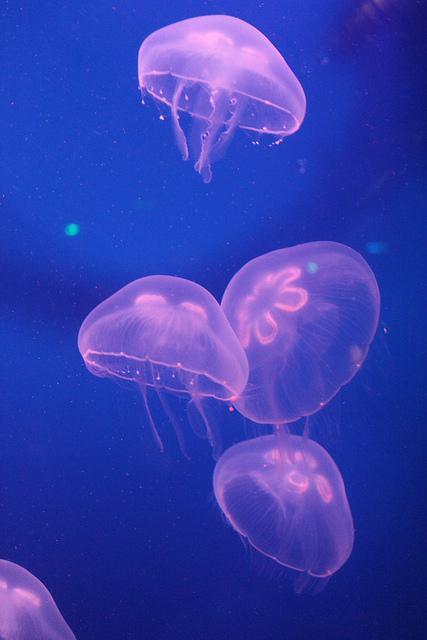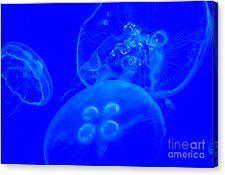The first image is the image on the left, the second image is the image on the right. Examine the images to the left and right. Is the description "In the image on the right, exactly 2  jellyfish are floating  above 1 smaller jellyfish." accurate? Answer yes or no. No. 